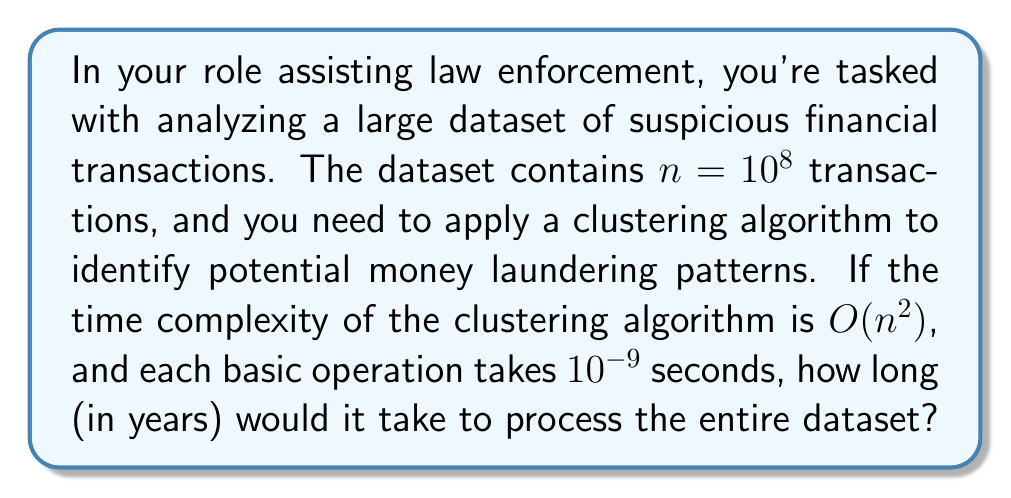Give your solution to this math problem. Let's break this down step-by-step:

1) The time complexity of the algorithm is $O(n^2)$, which means the number of operations is proportional to $n^2$.

2) We're given that $n = 10^8$, so the number of operations will be on the order of $(10^8)^2 = 10^{16}$.

3) Each operation takes $10^{-9}$ seconds.

4) To find the total time in seconds, we multiply the number of operations by the time per operation:

   $10^{16} \times 10^{-9} = 10^7$ seconds

5) Now we need to convert this to years:
   
   - There are 60 seconds in a minute
   - 60 minutes in an hour
   - 24 hours in a day
   - Approximately 365.25 days in a year (accounting for leap years)

6) Let's calculate:

   $$\frac{10^7 \text{ seconds}}{60 \times 60 \times 24 \times 365.25} = \frac{10^7}{31,557,600} \approx 0.3169 \text{ years}$$

Therefore, it would take approximately 0.3169 years to process the entire dataset.
Answer: Approximately 0.3169 years 